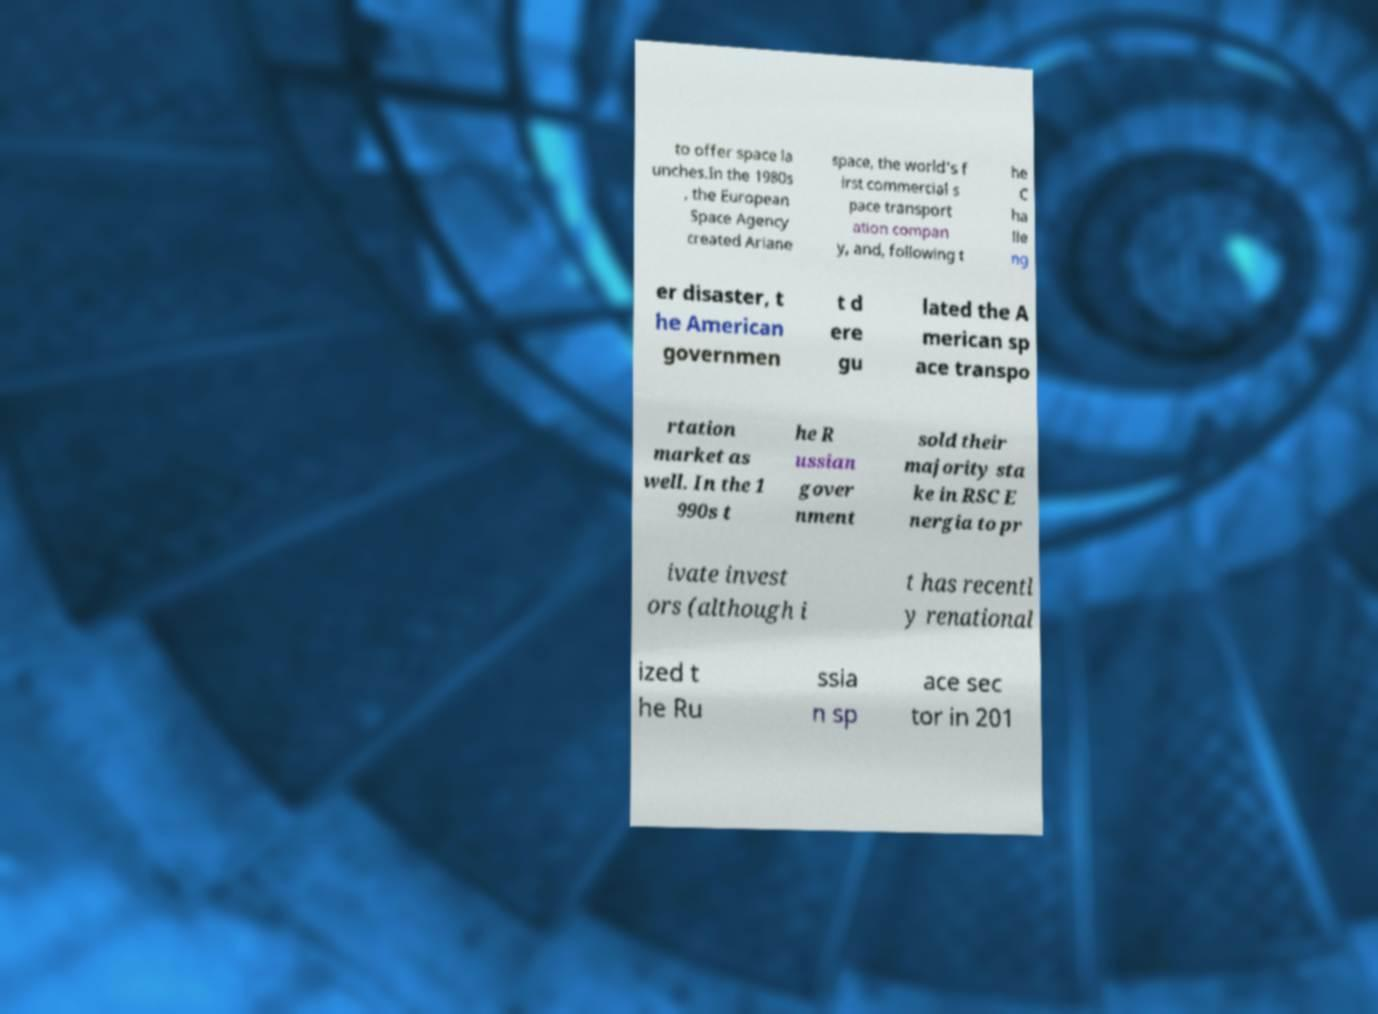Can you read and provide the text displayed in the image?This photo seems to have some interesting text. Can you extract and type it out for me? to offer space la unches.In the 1980s , the European Space Agency created Ariane space, the world's f irst commercial s pace transport ation compan y, and, following t he C ha lle ng er disaster, t he American governmen t d ere gu lated the A merican sp ace transpo rtation market as well. In the 1 990s t he R ussian gover nment sold their majority sta ke in RSC E nergia to pr ivate invest ors (although i t has recentl y renational ized t he Ru ssia n sp ace sec tor in 201 